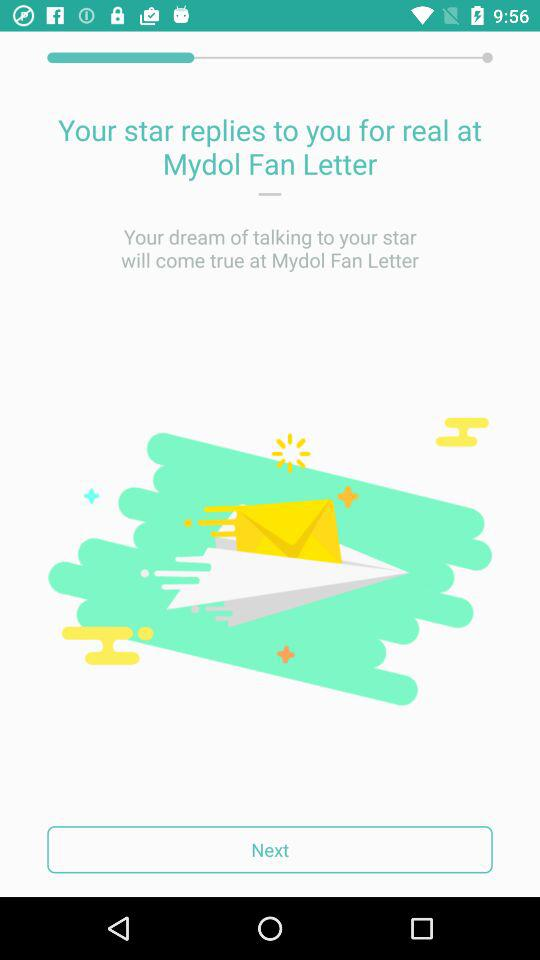What is the name of the application? The name of the application is "Mydol Fan Letter". 